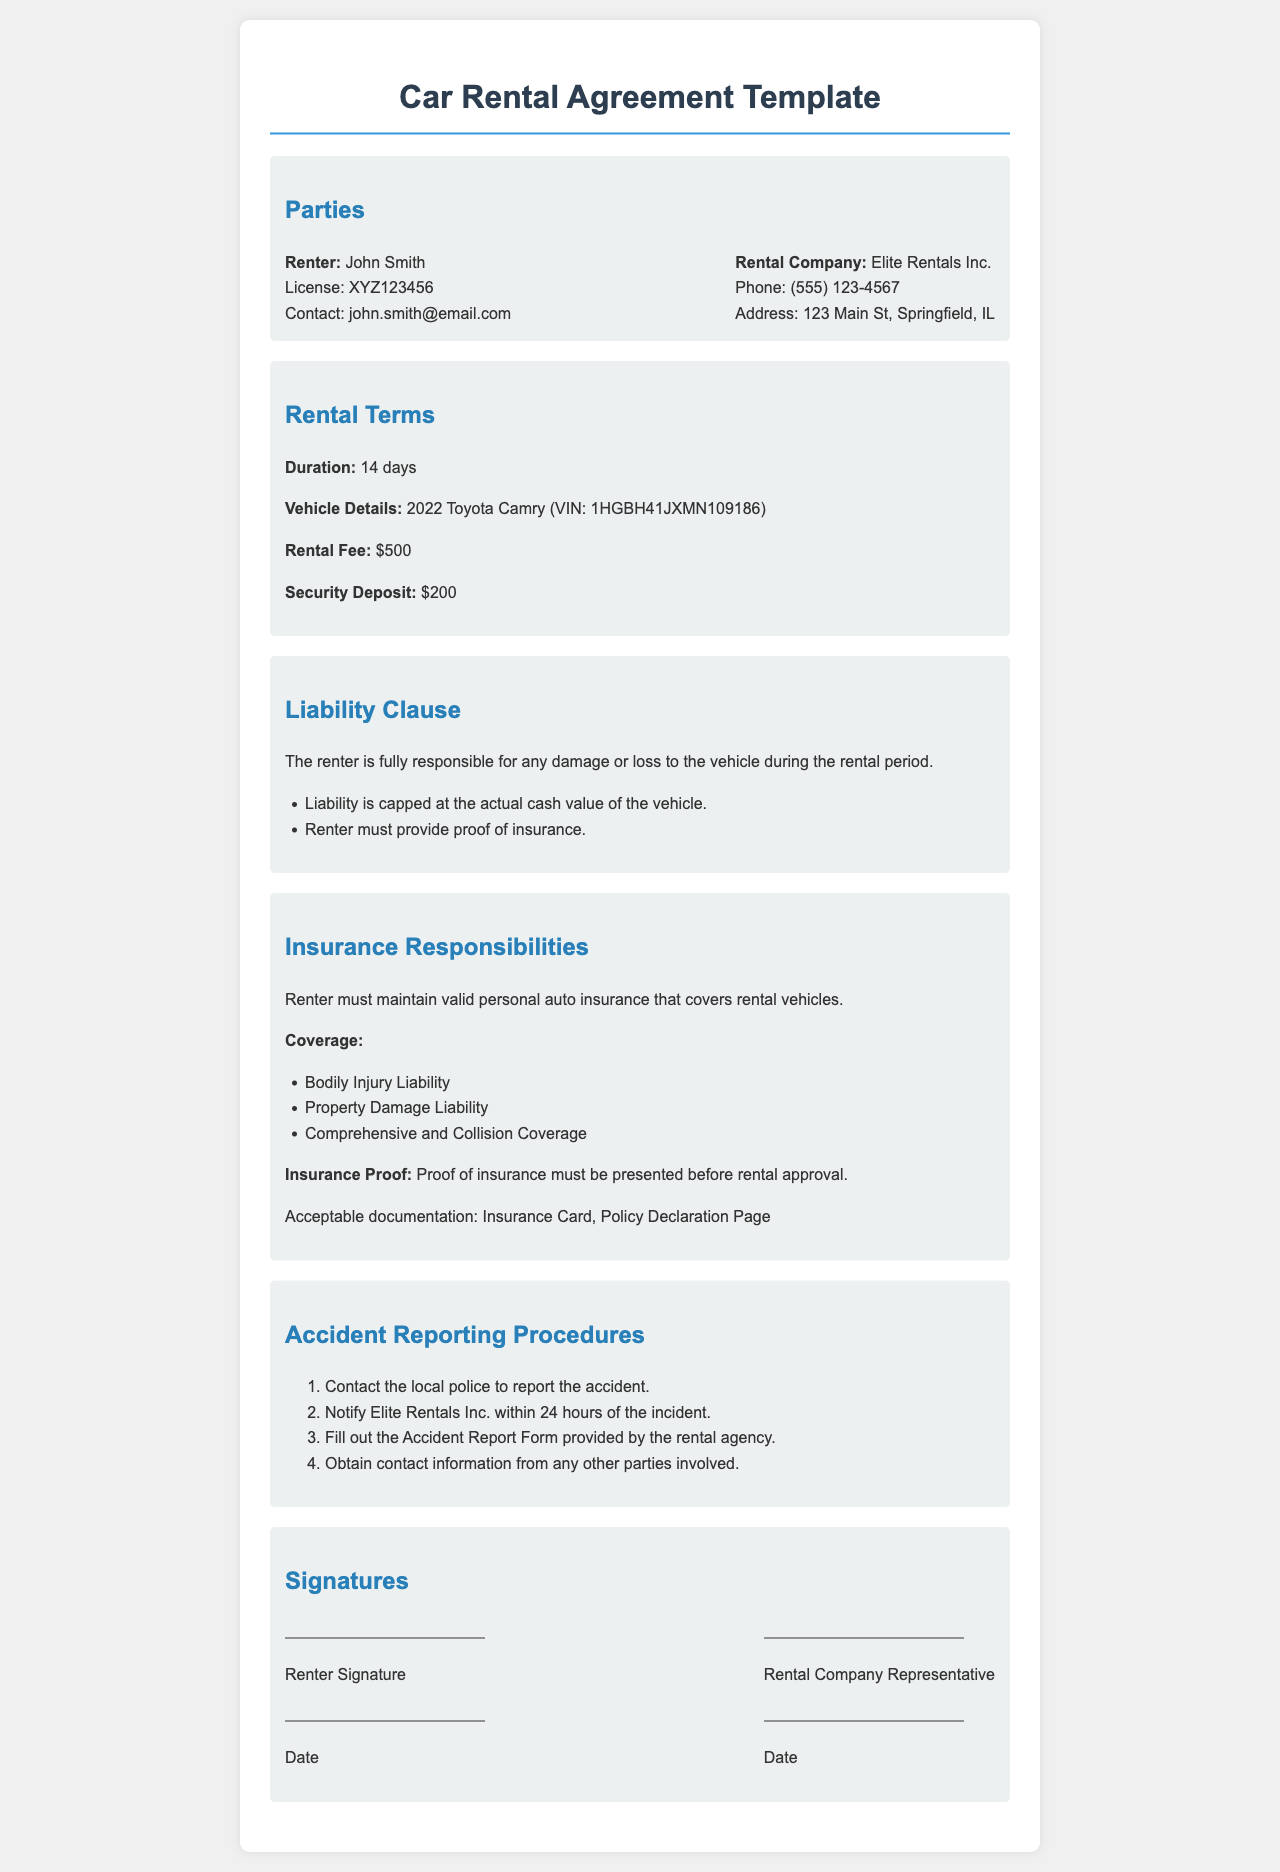What is the name of the renter? The name of the renter is mentioned in the Parties section of the document.
Answer: John Smith What is the rental fee amount? The rental fee is specified in the Rental Terms section.
Answer: $500 What is the duration of the rental? Duration is indicated in the Rental Terms section of the document.
Answer: 14 days What is the security deposit amount? The security deposit is listed in the Rental Terms section.
Answer: $200 What must the renter provide proof of? The document specifies what the renter must provide in the Liability Clause.
Answer: Insurance Which insurance coverage is required? The required coverages are listed under Insurance Responsibilities.
Answer: Bodily Injury Liability, Property Damage Liability, Comprehensive and Collision Coverage What is the first step in the accident reporting procedures? The accident reporting procedures outline the steps to follow after an incident.
Answer: Contact the local police How soon must the rental company be notified after an accident? The timeframe for notification is in the Accident Reporting Procedures section.
Answer: Within 24 hours What is the contact phone number of the rental company? The rental company's contact information is provided in the Parties section.
Answer: (555) 123-4567 